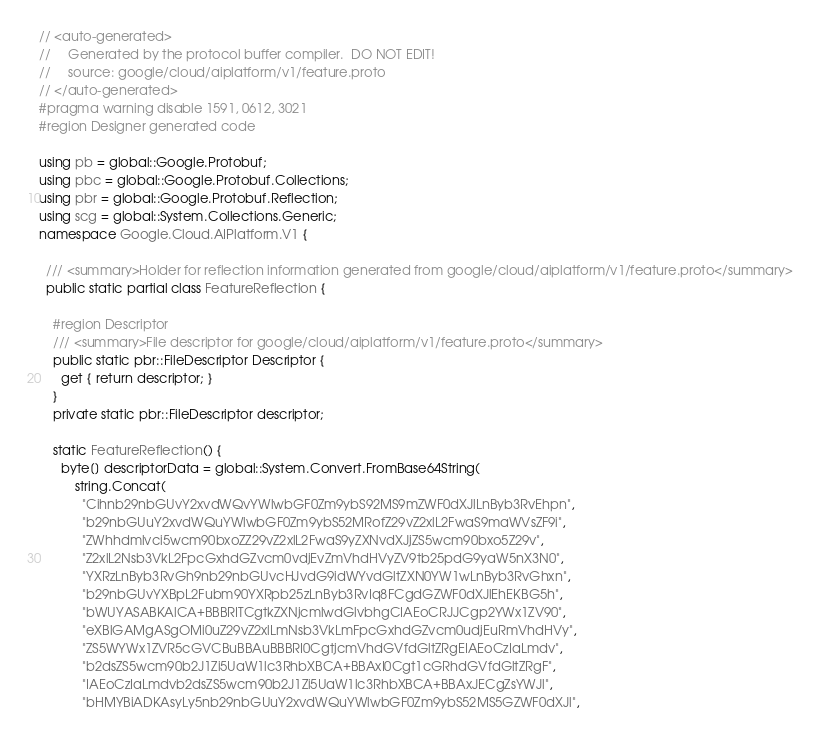<code> <loc_0><loc_0><loc_500><loc_500><_C#_>// <auto-generated>
//     Generated by the protocol buffer compiler.  DO NOT EDIT!
//     source: google/cloud/aiplatform/v1/feature.proto
// </auto-generated>
#pragma warning disable 1591, 0612, 3021
#region Designer generated code

using pb = global::Google.Protobuf;
using pbc = global::Google.Protobuf.Collections;
using pbr = global::Google.Protobuf.Reflection;
using scg = global::System.Collections.Generic;
namespace Google.Cloud.AIPlatform.V1 {

  /// <summary>Holder for reflection information generated from google/cloud/aiplatform/v1/feature.proto</summary>
  public static partial class FeatureReflection {

    #region Descriptor
    /// <summary>File descriptor for google/cloud/aiplatform/v1/feature.proto</summary>
    public static pbr::FileDescriptor Descriptor {
      get { return descriptor; }
    }
    private static pbr::FileDescriptor descriptor;

    static FeatureReflection() {
      byte[] descriptorData = global::System.Convert.FromBase64String(
          string.Concat(
            "Cihnb29nbGUvY2xvdWQvYWlwbGF0Zm9ybS92MS9mZWF0dXJlLnByb3RvEhpn",
            "b29nbGUuY2xvdWQuYWlwbGF0Zm9ybS52MRofZ29vZ2xlL2FwaS9maWVsZF9i",
            "ZWhhdmlvci5wcm90bxoZZ29vZ2xlL2FwaS9yZXNvdXJjZS5wcm90bxo5Z29v",
            "Z2xlL2Nsb3VkL2FpcGxhdGZvcm0vdjEvZmVhdHVyZV9tb25pdG9yaW5nX3N0",
            "YXRzLnByb3RvGh9nb29nbGUvcHJvdG9idWYvdGltZXN0YW1wLnByb3RvGhxn",
            "b29nbGUvYXBpL2Fubm90YXRpb25zLnByb3RvIq8FCgdGZWF0dXJlEhEKBG5h",
            "bWUYASABKAlCA+BBBRITCgtkZXNjcmlwdGlvbhgCIAEoCRJJCgp2YWx1ZV90",
            "eXBlGAMgASgOMi0uZ29vZ2xlLmNsb3VkLmFpcGxhdGZvcm0udjEuRmVhdHVy",
            "ZS5WYWx1ZVR5cGVCBuBBAuBBBRI0CgtjcmVhdGVfdGltZRgEIAEoCzIaLmdv",
            "b2dsZS5wcm90b2J1Zi5UaW1lc3RhbXBCA+BBAxI0Cgt1cGRhdGVfdGltZRgF",
            "IAEoCzIaLmdvb2dsZS5wcm90b2J1Zi5UaW1lc3RhbXBCA+BBAxJECgZsYWJl",
            "bHMYBiADKAsyLy5nb29nbGUuY2xvdWQuYWlwbGF0Zm9ybS52MS5GZWF0dXJl",</code> 